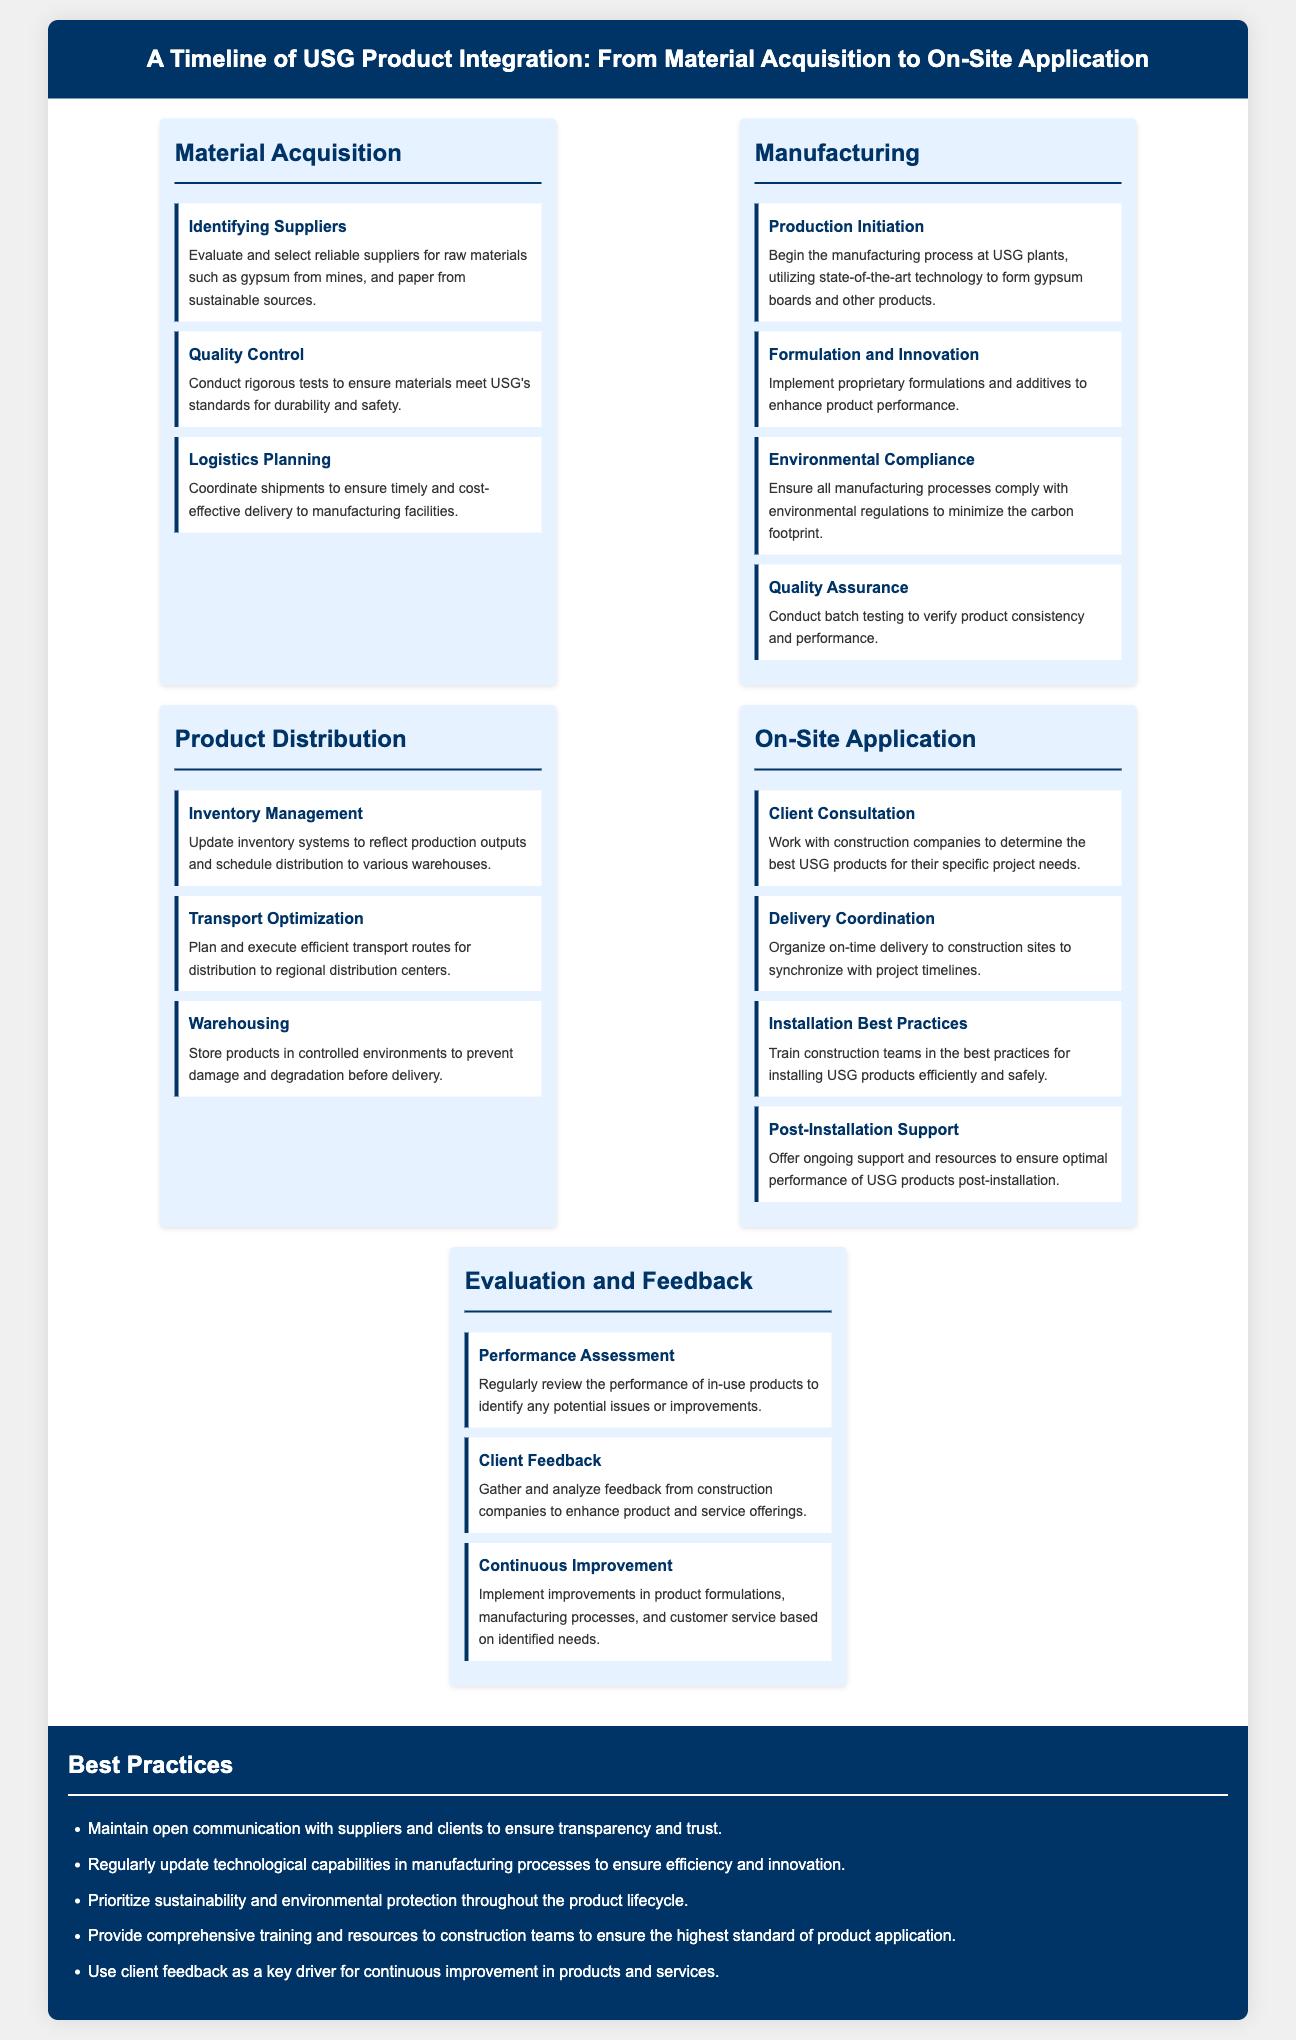What are the three main stages of product integration? The main stages of product integration are Material Acquisition, Manufacturing, and On-Site Application.
Answer: Material Acquisition, Manufacturing, On-Site Application How many milestones are listed under the Manufacturing stage? The milestones listed under the Manufacturing stage are Production Initiation, Formulation and Innovation, Environmental Compliance, and Quality Assurance, totaling four.
Answer: 4 What is the purpose of the Quality Control milestone in Material Acquisition? The purpose of the Quality Control milestone is to conduct rigorous tests to ensure materials meet USG's standards for durability and safety.
Answer: Ensure materials meet standards What is a key consideration in the best practices section? The best practices section emphasizes maintaining open communication with suppliers and clients for transparency and trust.
Answer: Open communication Which milestone involves working with construction companies? The milestone that involves working with construction companies is Client Consultation.
Answer: Client Consultation What is one aspect emphasized in the Environmental Compliance milestone? The Environmental Compliance milestone emphasizes ensuring all manufacturing processes comply with environmental regulations to minimize the carbon footprint.
Answer: Minimize carbon footprint How often should performance assessments be conducted according to the Evaluation and Feedback stage? Performance assessments should be conducted regularly.
Answer: Regularly What is the primary focus of the Continuous Improvement milestone? The primary focus of the Continuous Improvement milestone is to implement improvements based on identified needs in products and services.
Answer: Implement improvements What best practice is related to technology in manufacturing processes? The relevant best practice states to regularly update technological capabilities in manufacturing processes to ensure efficiency and innovation.
Answer: Update technological capabilities 